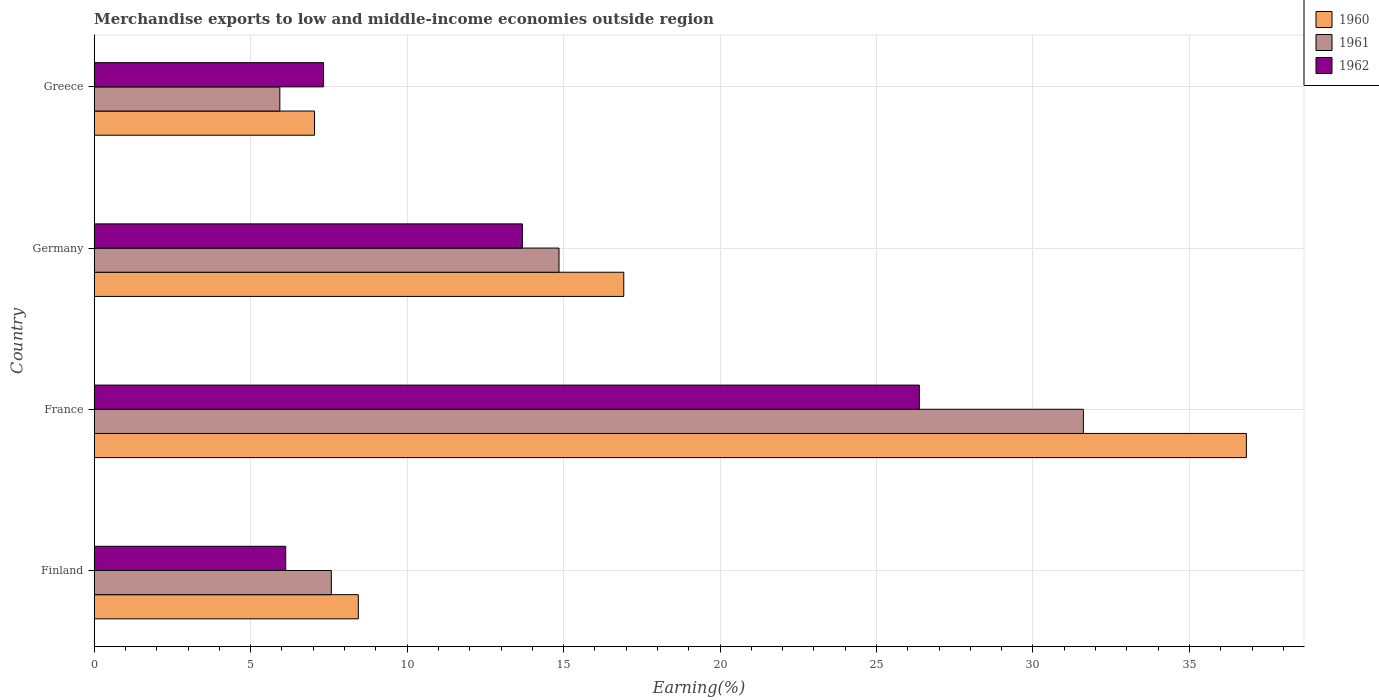How many different coloured bars are there?
Keep it short and to the point. 3. How many groups of bars are there?
Your response must be concise. 4. Are the number of bars per tick equal to the number of legend labels?
Provide a succinct answer. Yes. What is the label of the 2nd group of bars from the top?
Your response must be concise. Germany. What is the percentage of amount earned from merchandise exports in 1960 in Greece?
Provide a short and direct response. 7.04. Across all countries, what is the maximum percentage of amount earned from merchandise exports in 1962?
Provide a succinct answer. 26.37. Across all countries, what is the minimum percentage of amount earned from merchandise exports in 1961?
Give a very brief answer. 5.93. In which country was the percentage of amount earned from merchandise exports in 1962 minimum?
Offer a terse response. Finland. What is the total percentage of amount earned from merchandise exports in 1962 in the graph?
Keep it short and to the point. 53.5. What is the difference between the percentage of amount earned from merchandise exports in 1961 in Germany and that in Greece?
Your answer should be very brief. 8.92. What is the difference between the percentage of amount earned from merchandise exports in 1960 in Greece and the percentage of amount earned from merchandise exports in 1962 in France?
Provide a succinct answer. -19.33. What is the average percentage of amount earned from merchandise exports in 1960 per country?
Keep it short and to the point. 17.31. What is the difference between the percentage of amount earned from merchandise exports in 1962 and percentage of amount earned from merchandise exports in 1960 in Greece?
Offer a very short reply. 0.29. In how many countries, is the percentage of amount earned from merchandise exports in 1960 greater than 21 %?
Ensure brevity in your answer.  1. What is the ratio of the percentage of amount earned from merchandise exports in 1962 in France to that in Germany?
Ensure brevity in your answer.  1.93. Is the percentage of amount earned from merchandise exports in 1961 in Germany less than that in Greece?
Ensure brevity in your answer.  No. Is the difference between the percentage of amount earned from merchandise exports in 1962 in Finland and Greece greater than the difference between the percentage of amount earned from merchandise exports in 1960 in Finland and Greece?
Offer a terse response. No. What is the difference between the highest and the second highest percentage of amount earned from merchandise exports in 1962?
Make the answer very short. 12.69. What is the difference between the highest and the lowest percentage of amount earned from merchandise exports in 1960?
Provide a succinct answer. 29.78. Is the sum of the percentage of amount earned from merchandise exports in 1961 in Germany and Greece greater than the maximum percentage of amount earned from merchandise exports in 1962 across all countries?
Keep it short and to the point. No. What does the 3rd bar from the bottom in Greece represents?
Keep it short and to the point. 1962. What is the difference between two consecutive major ticks on the X-axis?
Give a very brief answer. 5. Does the graph contain any zero values?
Your answer should be very brief. No. Does the graph contain grids?
Keep it short and to the point. Yes. Where does the legend appear in the graph?
Your answer should be very brief. Top right. How many legend labels are there?
Ensure brevity in your answer.  3. What is the title of the graph?
Your response must be concise. Merchandise exports to low and middle-income economies outside region. Does "2014" appear as one of the legend labels in the graph?
Provide a short and direct response. No. What is the label or title of the X-axis?
Provide a succinct answer. Earning(%). What is the label or title of the Y-axis?
Your answer should be very brief. Country. What is the Earning(%) in 1960 in Finland?
Your response must be concise. 8.44. What is the Earning(%) in 1961 in Finland?
Your answer should be very brief. 7.58. What is the Earning(%) in 1962 in Finland?
Give a very brief answer. 6.12. What is the Earning(%) of 1960 in France?
Your answer should be compact. 36.82. What is the Earning(%) in 1961 in France?
Give a very brief answer. 31.61. What is the Earning(%) of 1962 in France?
Keep it short and to the point. 26.37. What is the Earning(%) in 1960 in Germany?
Give a very brief answer. 16.92. What is the Earning(%) in 1961 in Germany?
Offer a terse response. 14.85. What is the Earning(%) of 1962 in Germany?
Your answer should be compact. 13.68. What is the Earning(%) of 1960 in Greece?
Your answer should be compact. 7.04. What is the Earning(%) of 1961 in Greece?
Ensure brevity in your answer.  5.93. What is the Earning(%) in 1962 in Greece?
Provide a succinct answer. 7.33. Across all countries, what is the maximum Earning(%) in 1960?
Offer a terse response. 36.82. Across all countries, what is the maximum Earning(%) in 1961?
Your answer should be very brief. 31.61. Across all countries, what is the maximum Earning(%) in 1962?
Provide a short and direct response. 26.37. Across all countries, what is the minimum Earning(%) of 1960?
Ensure brevity in your answer.  7.04. Across all countries, what is the minimum Earning(%) of 1961?
Offer a very short reply. 5.93. Across all countries, what is the minimum Earning(%) in 1962?
Your answer should be compact. 6.12. What is the total Earning(%) in 1960 in the graph?
Give a very brief answer. 69.22. What is the total Earning(%) in 1961 in the graph?
Provide a short and direct response. 59.97. What is the total Earning(%) of 1962 in the graph?
Your answer should be compact. 53.5. What is the difference between the Earning(%) of 1960 in Finland and that in France?
Offer a terse response. -28.38. What is the difference between the Earning(%) in 1961 in Finland and that in France?
Make the answer very short. -24.03. What is the difference between the Earning(%) of 1962 in Finland and that in France?
Ensure brevity in your answer.  -20.25. What is the difference between the Earning(%) in 1960 in Finland and that in Germany?
Your answer should be compact. -8.48. What is the difference between the Earning(%) in 1961 in Finland and that in Germany?
Offer a very short reply. -7.28. What is the difference between the Earning(%) in 1962 in Finland and that in Germany?
Make the answer very short. -7.56. What is the difference between the Earning(%) in 1960 in Finland and that in Greece?
Provide a succinct answer. 1.4. What is the difference between the Earning(%) of 1961 in Finland and that in Greece?
Ensure brevity in your answer.  1.65. What is the difference between the Earning(%) of 1962 in Finland and that in Greece?
Provide a succinct answer. -1.21. What is the difference between the Earning(%) in 1960 in France and that in Germany?
Offer a terse response. 19.9. What is the difference between the Earning(%) of 1961 in France and that in Germany?
Offer a terse response. 16.76. What is the difference between the Earning(%) in 1962 in France and that in Germany?
Your answer should be very brief. 12.69. What is the difference between the Earning(%) of 1960 in France and that in Greece?
Your response must be concise. 29.78. What is the difference between the Earning(%) in 1961 in France and that in Greece?
Ensure brevity in your answer.  25.68. What is the difference between the Earning(%) in 1962 in France and that in Greece?
Your response must be concise. 19.04. What is the difference between the Earning(%) of 1960 in Germany and that in Greece?
Your answer should be very brief. 9.88. What is the difference between the Earning(%) in 1961 in Germany and that in Greece?
Your answer should be very brief. 8.92. What is the difference between the Earning(%) in 1962 in Germany and that in Greece?
Your response must be concise. 6.35. What is the difference between the Earning(%) of 1960 in Finland and the Earning(%) of 1961 in France?
Ensure brevity in your answer.  -23.17. What is the difference between the Earning(%) of 1960 in Finland and the Earning(%) of 1962 in France?
Offer a very short reply. -17.93. What is the difference between the Earning(%) of 1961 in Finland and the Earning(%) of 1962 in France?
Your answer should be very brief. -18.79. What is the difference between the Earning(%) of 1960 in Finland and the Earning(%) of 1961 in Germany?
Provide a short and direct response. -6.41. What is the difference between the Earning(%) of 1960 in Finland and the Earning(%) of 1962 in Germany?
Provide a succinct answer. -5.24. What is the difference between the Earning(%) of 1961 in Finland and the Earning(%) of 1962 in Germany?
Your response must be concise. -6.11. What is the difference between the Earning(%) in 1960 in Finland and the Earning(%) in 1961 in Greece?
Your answer should be very brief. 2.51. What is the difference between the Earning(%) of 1960 in Finland and the Earning(%) of 1962 in Greece?
Ensure brevity in your answer.  1.11. What is the difference between the Earning(%) of 1961 in Finland and the Earning(%) of 1962 in Greece?
Ensure brevity in your answer.  0.25. What is the difference between the Earning(%) in 1960 in France and the Earning(%) in 1961 in Germany?
Offer a very short reply. 21.97. What is the difference between the Earning(%) in 1960 in France and the Earning(%) in 1962 in Germany?
Your answer should be compact. 23.14. What is the difference between the Earning(%) in 1961 in France and the Earning(%) in 1962 in Germany?
Keep it short and to the point. 17.93. What is the difference between the Earning(%) in 1960 in France and the Earning(%) in 1961 in Greece?
Your answer should be compact. 30.89. What is the difference between the Earning(%) of 1960 in France and the Earning(%) of 1962 in Greece?
Your answer should be compact. 29.49. What is the difference between the Earning(%) of 1961 in France and the Earning(%) of 1962 in Greece?
Offer a very short reply. 24.28. What is the difference between the Earning(%) of 1960 in Germany and the Earning(%) of 1961 in Greece?
Make the answer very short. 10.99. What is the difference between the Earning(%) in 1960 in Germany and the Earning(%) in 1962 in Greece?
Provide a short and direct response. 9.59. What is the difference between the Earning(%) of 1961 in Germany and the Earning(%) of 1962 in Greece?
Your answer should be compact. 7.52. What is the average Earning(%) in 1960 per country?
Your answer should be very brief. 17.31. What is the average Earning(%) in 1961 per country?
Ensure brevity in your answer.  14.99. What is the average Earning(%) of 1962 per country?
Your answer should be compact. 13.38. What is the difference between the Earning(%) of 1960 and Earning(%) of 1961 in Finland?
Offer a terse response. 0.86. What is the difference between the Earning(%) in 1960 and Earning(%) in 1962 in Finland?
Offer a very short reply. 2.32. What is the difference between the Earning(%) of 1961 and Earning(%) of 1962 in Finland?
Offer a terse response. 1.46. What is the difference between the Earning(%) of 1960 and Earning(%) of 1961 in France?
Make the answer very short. 5.21. What is the difference between the Earning(%) in 1960 and Earning(%) in 1962 in France?
Make the answer very short. 10.45. What is the difference between the Earning(%) of 1961 and Earning(%) of 1962 in France?
Provide a short and direct response. 5.24. What is the difference between the Earning(%) of 1960 and Earning(%) of 1961 in Germany?
Your answer should be very brief. 2.07. What is the difference between the Earning(%) of 1960 and Earning(%) of 1962 in Germany?
Keep it short and to the point. 3.24. What is the difference between the Earning(%) of 1961 and Earning(%) of 1962 in Germany?
Offer a very short reply. 1.17. What is the difference between the Earning(%) of 1960 and Earning(%) of 1961 in Greece?
Your response must be concise. 1.11. What is the difference between the Earning(%) in 1960 and Earning(%) in 1962 in Greece?
Ensure brevity in your answer.  -0.29. What is the difference between the Earning(%) of 1961 and Earning(%) of 1962 in Greece?
Provide a succinct answer. -1.4. What is the ratio of the Earning(%) in 1960 in Finland to that in France?
Offer a very short reply. 0.23. What is the ratio of the Earning(%) in 1961 in Finland to that in France?
Your response must be concise. 0.24. What is the ratio of the Earning(%) of 1962 in Finland to that in France?
Offer a very short reply. 0.23. What is the ratio of the Earning(%) of 1960 in Finland to that in Germany?
Your response must be concise. 0.5. What is the ratio of the Earning(%) in 1961 in Finland to that in Germany?
Provide a short and direct response. 0.51. What is the ratio of the Earning(%) of 1962 in Finland to that in Germany?
Your response must be concise. 0.45. What is the ratio of the Earning(%) of 1960 in Finland to that in Greece?
Make the answer very short. 1.2. What is the ratio of the Earning(%) of 1961 in Finland to that in Greece?
Your response must be concise. 1.28. What is the ratio of the Earning(%) in 1962 in Finland to that in Greece?
Keep it short and to the point. 0.83. What is the ratio of the Earning(%) in 1960 in France to that in Germany?
Your answer should be very brief. 2.18. What is the ratio of the Earning(%) of 1961 in France to that in Germany?
Give a very brief answer. 2.13. What is the ratio of the Earning(%) in 1962 in France to that in Germany?
Provide a succinct answer. 1.93. What is the ratio of the Earning(%) of 1960 in France to that in Greece?
Provide a succinct answer. 5.23. What is the ratio of the Earning(%) of 1961 in France to that in Greece?
Give a very brief answer. 5.33. What is the ratio of the Earning(%) of 1962 in France to that in Greece?
Provide a succinct answer. 3.6. What is the ratio of the Earning(%) in 1960 in Germany to that in Greece?
Provide a succinct answer. 2.4. What is the ratio of the Earning(%) of 1961 in Germany to that in Greece?
Provide a succinct answer. 2.5. What is the ratio of the Earning(%) in 1962 in Germany to that in Greece?
Provide a short and direct response. 1.87. What is the difference between the highest and the second highest Earning(%) in 1960?
Make the answer very short. 19.9. What is the difference between the highest and the second highest Earning(%) in 1961?
Your answer should be compact. 16.76. What is the difference between the highest and the second highest Earning(%) in 1962?
Keep it short and to the point. 12.69. What is the difference between the highest and the lowest Earning(%) in 1960?
Make the answer very short. 29.78. What is the difference between the highest and the lowest Earning(%) in 1961?
Offer a very short reply. 25.68. What is the difference between the highest and the lowest Earning(%) in 1962?
Give a very brief answer. 20.25. 